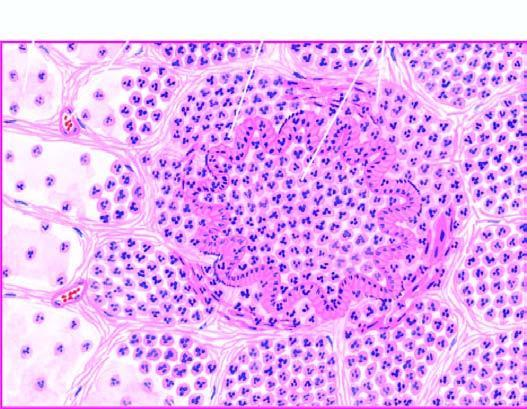what are filled with exudate consisting chiefly of neutrophils?
Answer the question using a single word or phrase. Bronchioles as well as the adjacent alveoli 